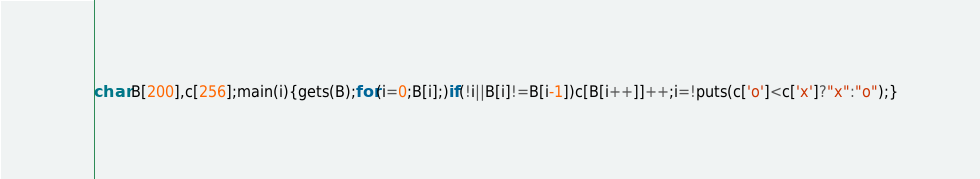<code> <loc_0><loc_0><loc_500><loc_500><_C_>char B[200],c[256];main(i){gets(B);for(i=0;B[i];)if(!i||B[i]!=B[i-1])c[B[i++]]++;i=!puts(c['o']<c['x']?"x":"o");}</code> 